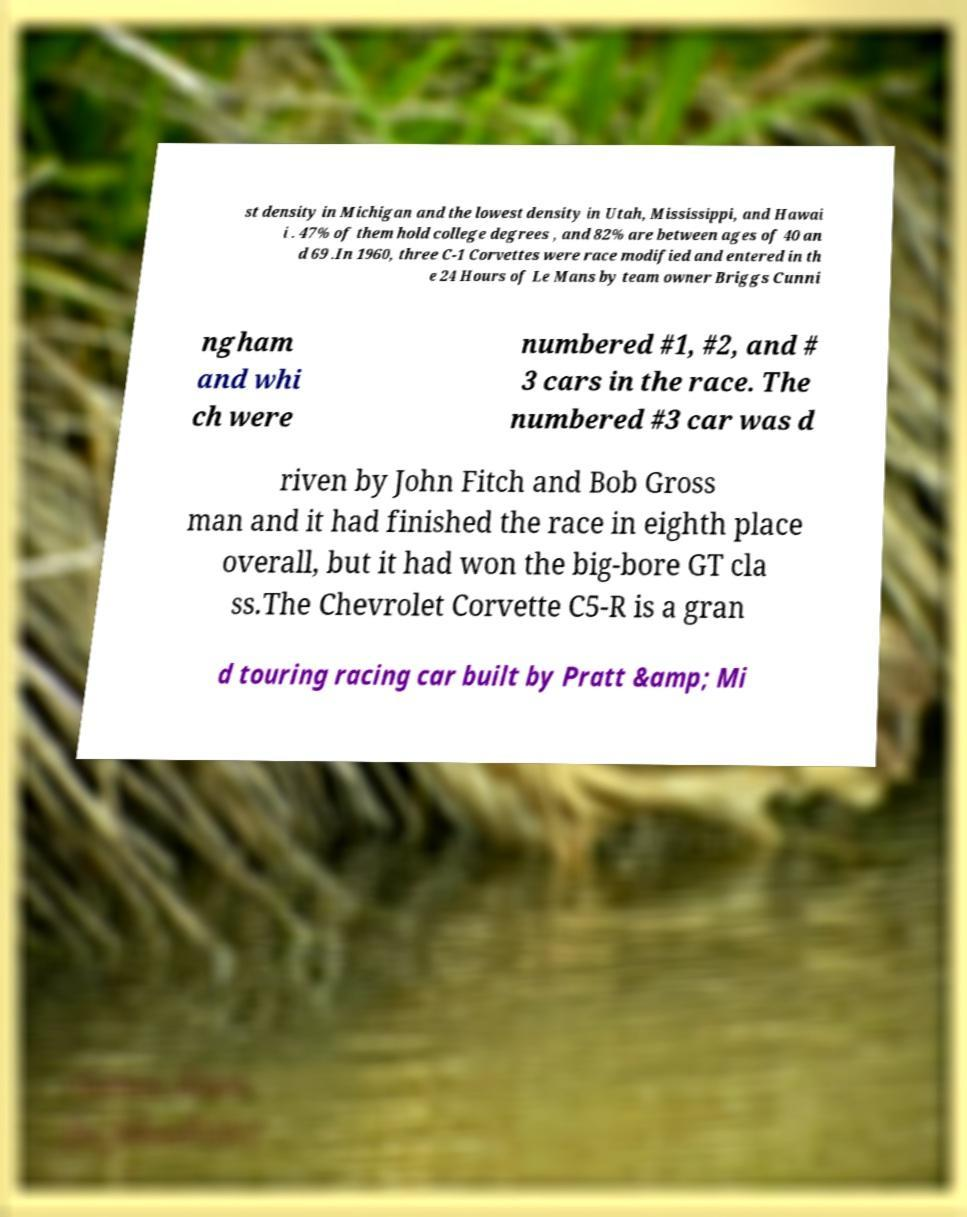Can you accurately transcribe the text from the provided image for me? st density in Michigan and the lowest density in Utah, Mississippi, and Hawai i . 47% of them hold college degrees , and 82% are between ages of 40 an d 69 .In 1960, three C-1 Corvettes were race modified and entered in th e 24 Hours of Le Mans by team owner Briggs Cunni ngham and whi ch were numbered #1, #2, and # 3 cars in the race. The numbered #3 car was d riven by John Fitch and Bob Gross man and it had finished the race in eighth place overall, but it had won the big-bore GT cla ss.The Chevrolet Corvette C5-R is a gran d touring racing car built by Pratt &amp; Mi 